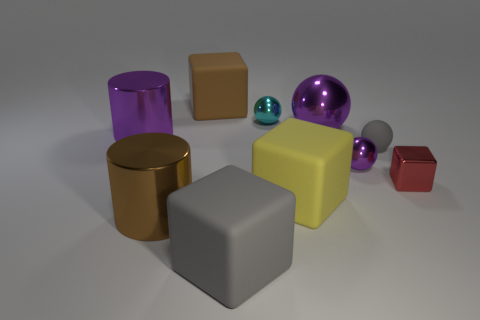Subtract all big purple metallic balls. How many balls are left? 3 Subtract all purple balls. How many balls are left? 2 Subtract all cylinders. How many objects are left? 8 Subtract 3 blocks. How many blocks are left? 1 Subtract 0 brown balls. How many objects are left? 10 Subtract all gray balls. Subtract all brown blocks. How many balls are left? 3 Subtract all blue balls. How many red cubes are left? 1 Subtract all tiny purple metallic balls. Subtract all tiny matte things. How many objects are left? 8 Add 6 cyan spheres. How many cyan spheres are left? 7 Add 5 red metal cubes. How many red metal cubes exist? 6 